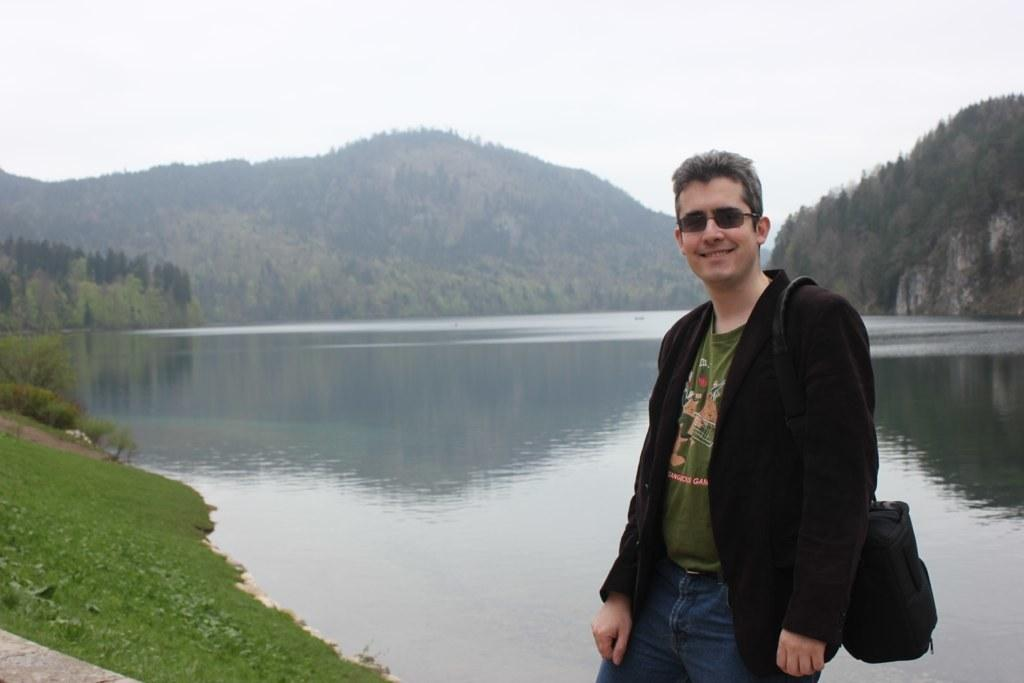What is the main subject of the image? The main subject of the image is a man. What is the man wearing in the image? The man is wearing goggles in the image. What is the man carrying in the image? The man is carrying a bag in the image. What is the man's facial expression in the image? The man is smiling in the image. What can be seen in the background of the image? In the background of the image, there is grass, water, trees, mountains, and the sky. What type of pain is the man experiencing in the image? There is no indication in the image that the man is experiencing any pain. What kind of lunch is the man eating in the image? There is no lunch present in the image; the man is carrying a bag. 